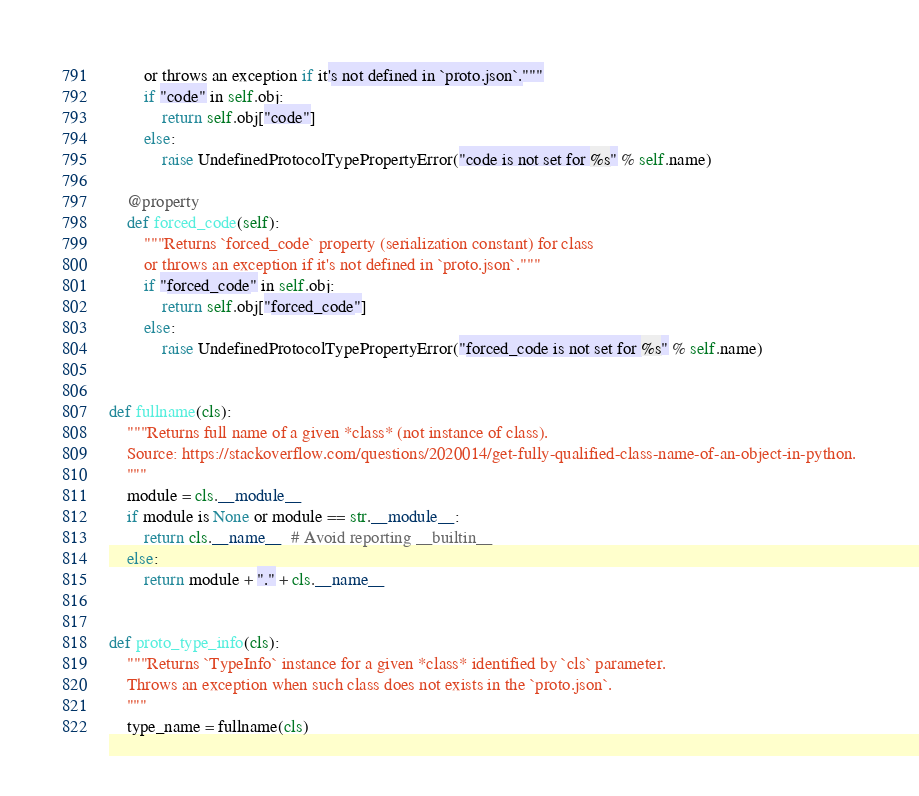<code> <loc_0><loc_0><loc_500><loc_500><_Python_>        or throws an exception if it's not defined in `proto.json`."""
        if "code" in self.obj:
            return self.obj["code"]
        else:
            raise UndefinedProtocolTypePropertyError("code is not set for %s" % self.name)

    @property
    def forced_code(self):
        """Returns `forced_code` property (serialization constant) for class
        or throws an exception if it's not defined in `proto.json`."""
        if "forced_code" in self.obj:
            return self.obj["forced_code"]
        else:
            raise UndefinedProtocolTypePropertyError("forced_code is not set for %s" % self.name)


def fullname(cls):
    """Returns full name of a given *class* (not instance of class).
    Source: https://stackoverflow.com/questions/2020014/get-fully-qualified-class-name-of-an-object-in-python.
    """
    module = cls.__module__
    if module is None or module == str.__module__:
        return cls.__name__  # Avoid reporting __builtin__
    else:
        return module + "." + cls.__name__


def proto_type_info(cls):
    """Returns `TypeInfo` instance for a given *class* identified by `cls` parameter.
    Throws an exception when such class does not exists in the `proto.json`.
    """
    type_name = fullname(cls)
</code> 